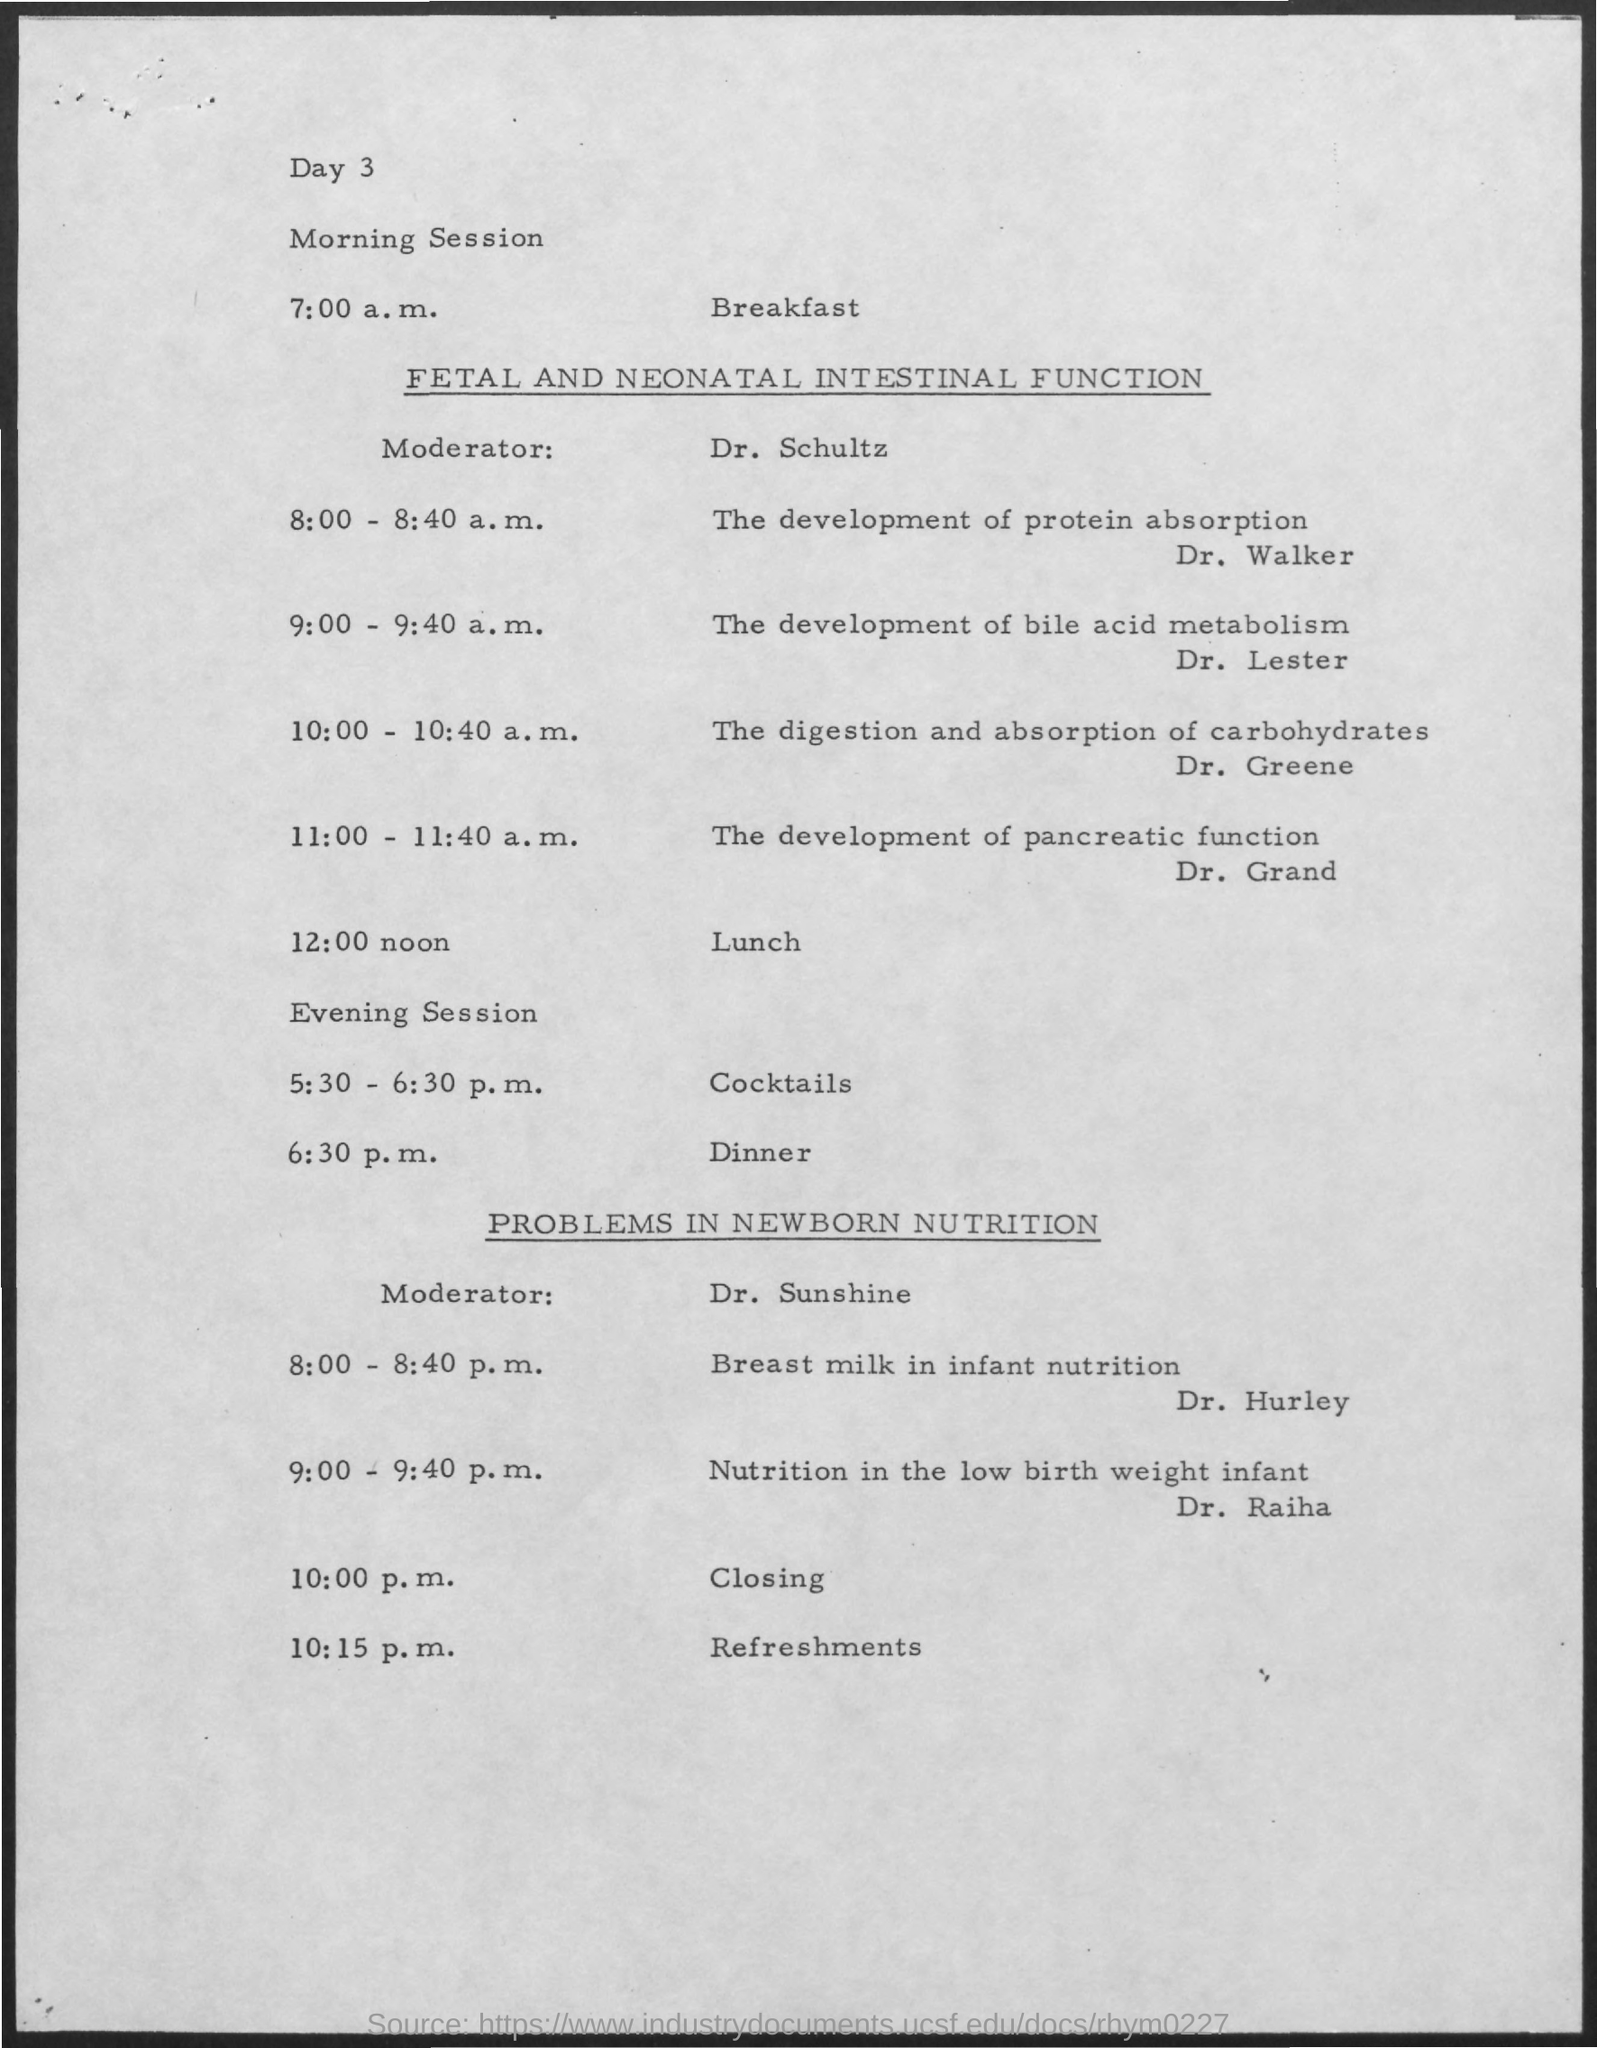Point out several critical features in this image. Breakfast is scheduled to commence at 7:00 a.m.... 